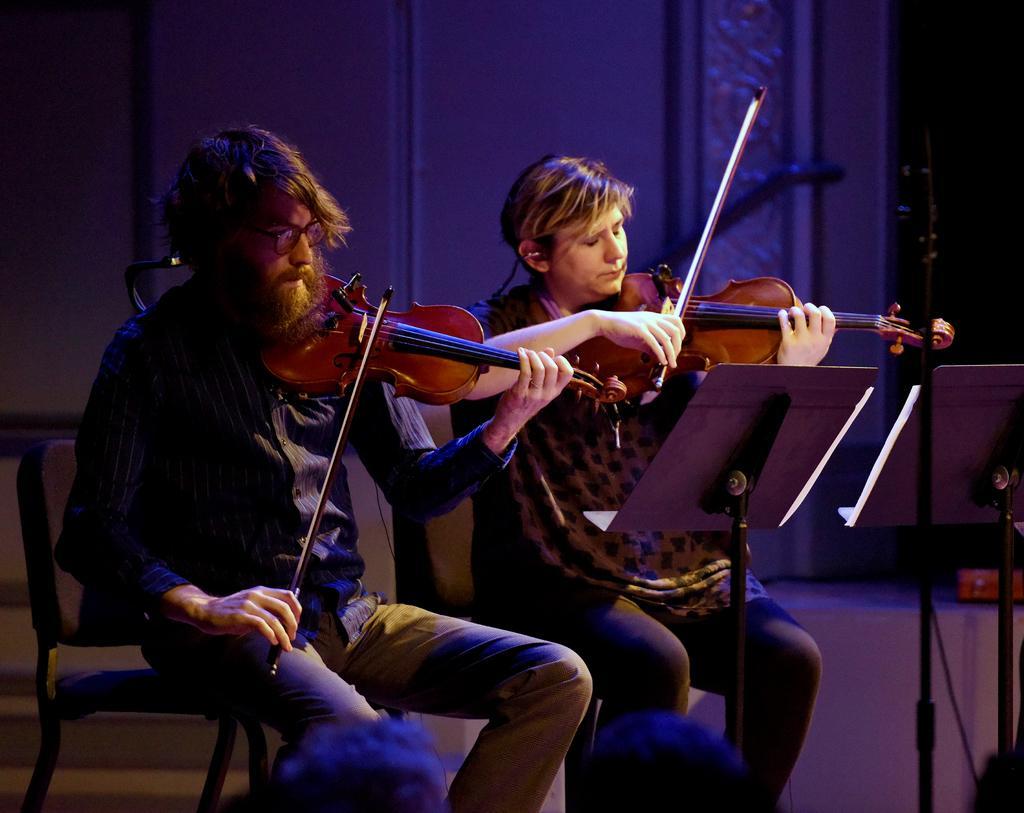Describe this image in one or two sentences. In this picture we can see a man and a woman sitting on chairs and playing violins, on the right side there are two strands, in the background there is a wall. 